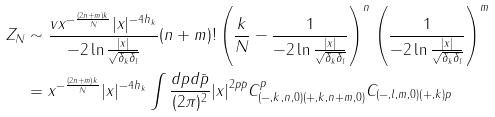Convert formula to latex. <formula><loc_0><loc_0><loc_500><loc_500>Z _ { N } & \sim \frac { v x ^ { - \frac { ( 2 n + m ) k } { N } } | x | ^ { - 4 h _ { k } } } { - 2 \ln \frac { | x | } { \sqrt { \delta _ { k } \delta _ { l } } } } ( n + m ) ! \left ( \frac { k } { N } - \frac { 1 } { - 2 \ln \frac { | x | } { \sqrt { \delta _ { k } \delta _ { l } } } } \right ) ^ { n } \left ( \frac { 1 } { - 2 \ln \frac { | x | } { \sqrt { \delta _ { k } \delta _ { l } } } } \right ) ^ { m } \\ & = x ^ { - \frac { ( 2 n + m ) k } { N } } | x | ^ { - 4 h _ { k } } \int \frac { d p d \bar { p } } { ( 2 \pi ) ^ { 2 } } { | x | } ^ { 2 p \bar { p } } C _ { ( - , k , n , 0 ) ( + , k , n + m , 0 ) } ^ { p } C _ { ( - , l , m , 0 ) ( + , k ) p }</formula> 